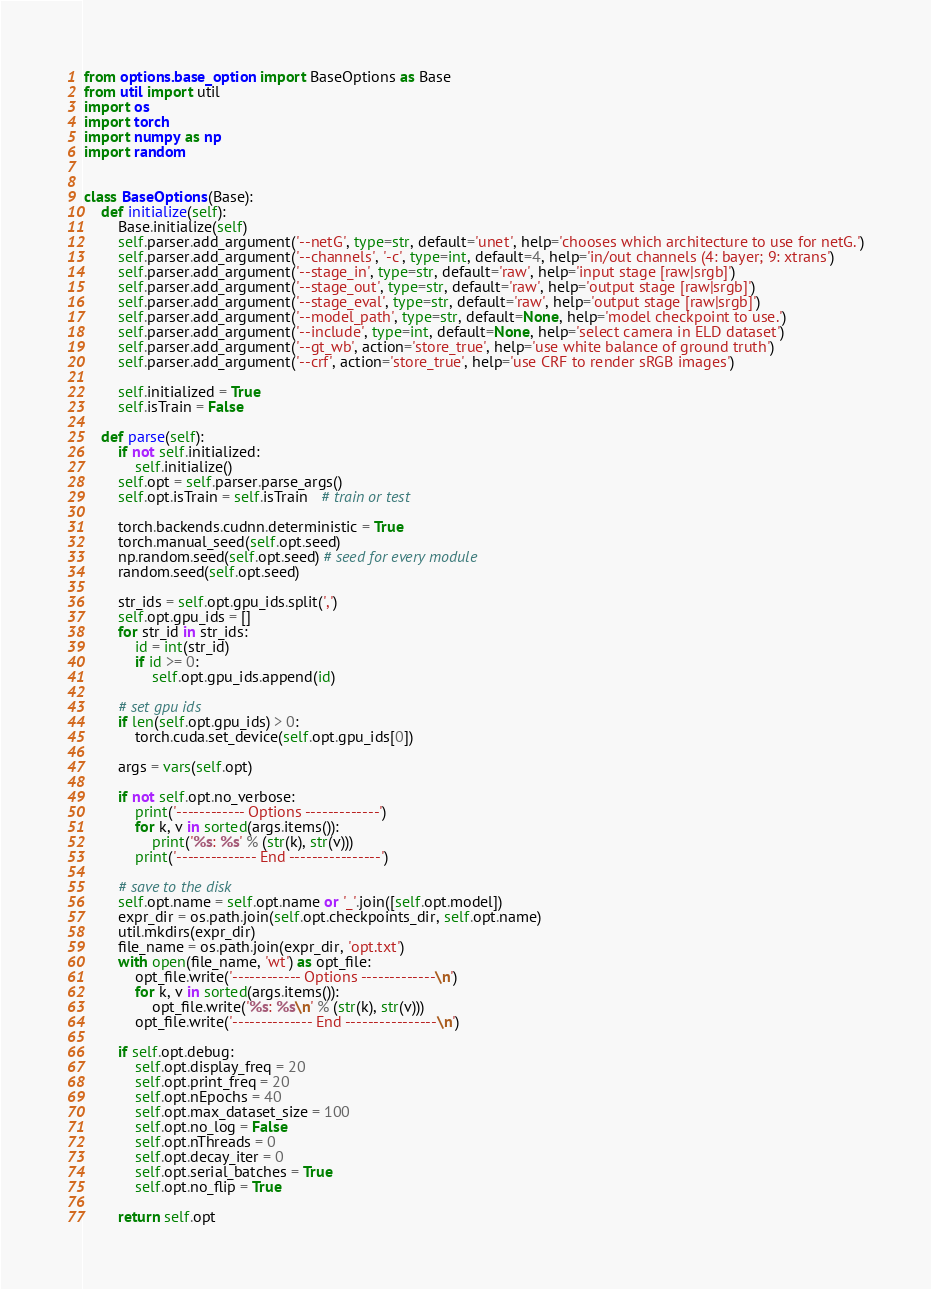Convert code to text. <code><loc_0><loc_0><loc_500><loc_500><_Python_>from options.base_option import BaseOptions as Base
from util import util
import os
import torch
import numpy as np
import random


class BaseOptions(Base):
    def initialize(self):
        Base.initialize(self)
        self.parser.add_argument('--netG', type=str, default='unet', help='chooses which architecture to use for netG.')
        self.parser.add_argument('--channels', '-c', type=int, default=4, help='in/out channels (4: bayer; 9: xtrans')
        self.parser.add_argument('--stage_in', type=str, default='raw', help='input stage [raw|srgb]')
        self.parser.add_argument('--stage_out', type=str, default='raw', help='output stage [raw|srgb]')
        self.parser.add_argument('--stage_eval', type=str, default='raw', help='output stage [raw|srgb]')
        self.parser.add_argument('--model_path', type=str, default=None, help='model checkpoint to use.')
        self.parser.add_argument('--include', type=int, default=None, help='select camera in ELD dataset')
        self.parser.add_argument('--gt_wb', action='store_true', help='use white balance of ground truth')
        self.parser.add_argument('--crf', action='store_true', help='use CRF to render sRGB images')

        self.initialized = True
        self.isTrain = False

    def parse(self):
        if not self.initialized:
            self.initialize()
        self.opt = self.parser.parse_args()
        self.opt.isTrain = self.isTrain   # train or test

        torch.backends.cudnn.deterministic = True
        torch.manual_seed(self.opt.seed)
        np.random.seed(self.opt.seed) # seed for every module
        random.seed(self.opt.seed)

        str_ids = self.opt.gpu_ids.split(',')
        self.opt.gpu_ids = []
        for str_id in str_ids:
            id = int(str_id)
            if id >= 0:
                self.opt.gpu_ids.append(id)

        # set gpu ids
        if len(self.opt.gpu_ids) > 0:
            torch.cuda.set_device(self.opt.gpu_ids[0])

        args = vars(self.opt)

        if not self.opt.no_verbose:
            print('------------ Options -------------')
            for k, v in sorted(args.items()):
                print('%s: %s' % (str(k), str(v)))
            print('-------------- End ----------------')

        # save to the disk
        self.opt.name = self.opt.name or '_'.join([self.opt.model])
        expr_dir = os.path.join(self.opt.checkpoints_dir, self.opt.name)
        util.mkdirs(expr_dir)
        file_name = os.path.join(expr_dir, 'opt.txt')
        with open(file_name, 'wt') as opt_file:
            opt_file.write('------------ Options -------------\n')
            for k, v in sorted(args.items()):
                opt_file.write('%s: %s\n' % (str(k), str(v)))
            opt_file.write('-------------- End ----------------\n')

        if self.opt.debug:
            self.opt.display_freq = 20
            self.opt.print_freq = 20
            self.opt.nEpochs = 40
            self.opt.max_dataset_size = 100
            self.opt.no_log = False
            self.opt.nThreads = 0
            self.opt.decay_iter = 0
            self.opt.serial_batches = True
            self.opt.no_flip = True
        
        return self.opt
</code> 